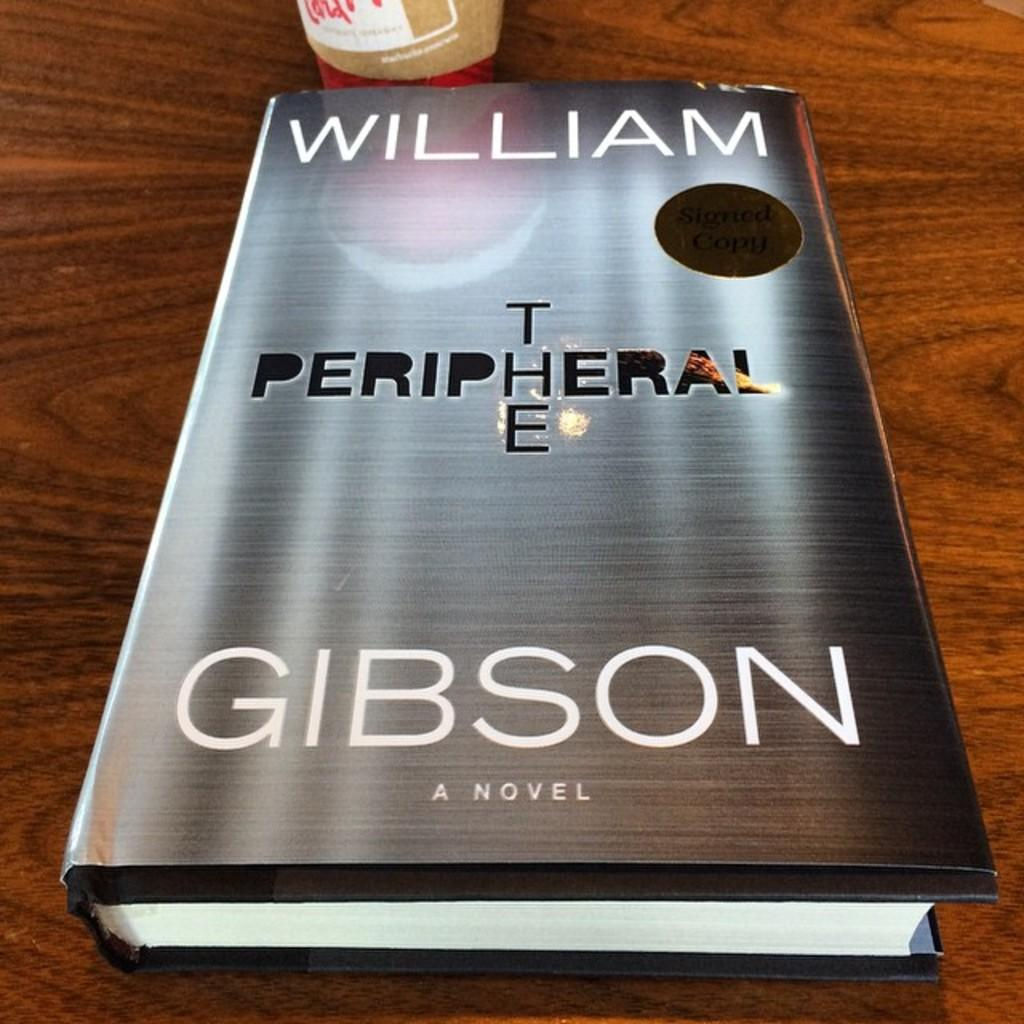<image>
Present a compact description of the photo's key features. An cut out .looking title forms the cover of The Peripheral by Gibson 